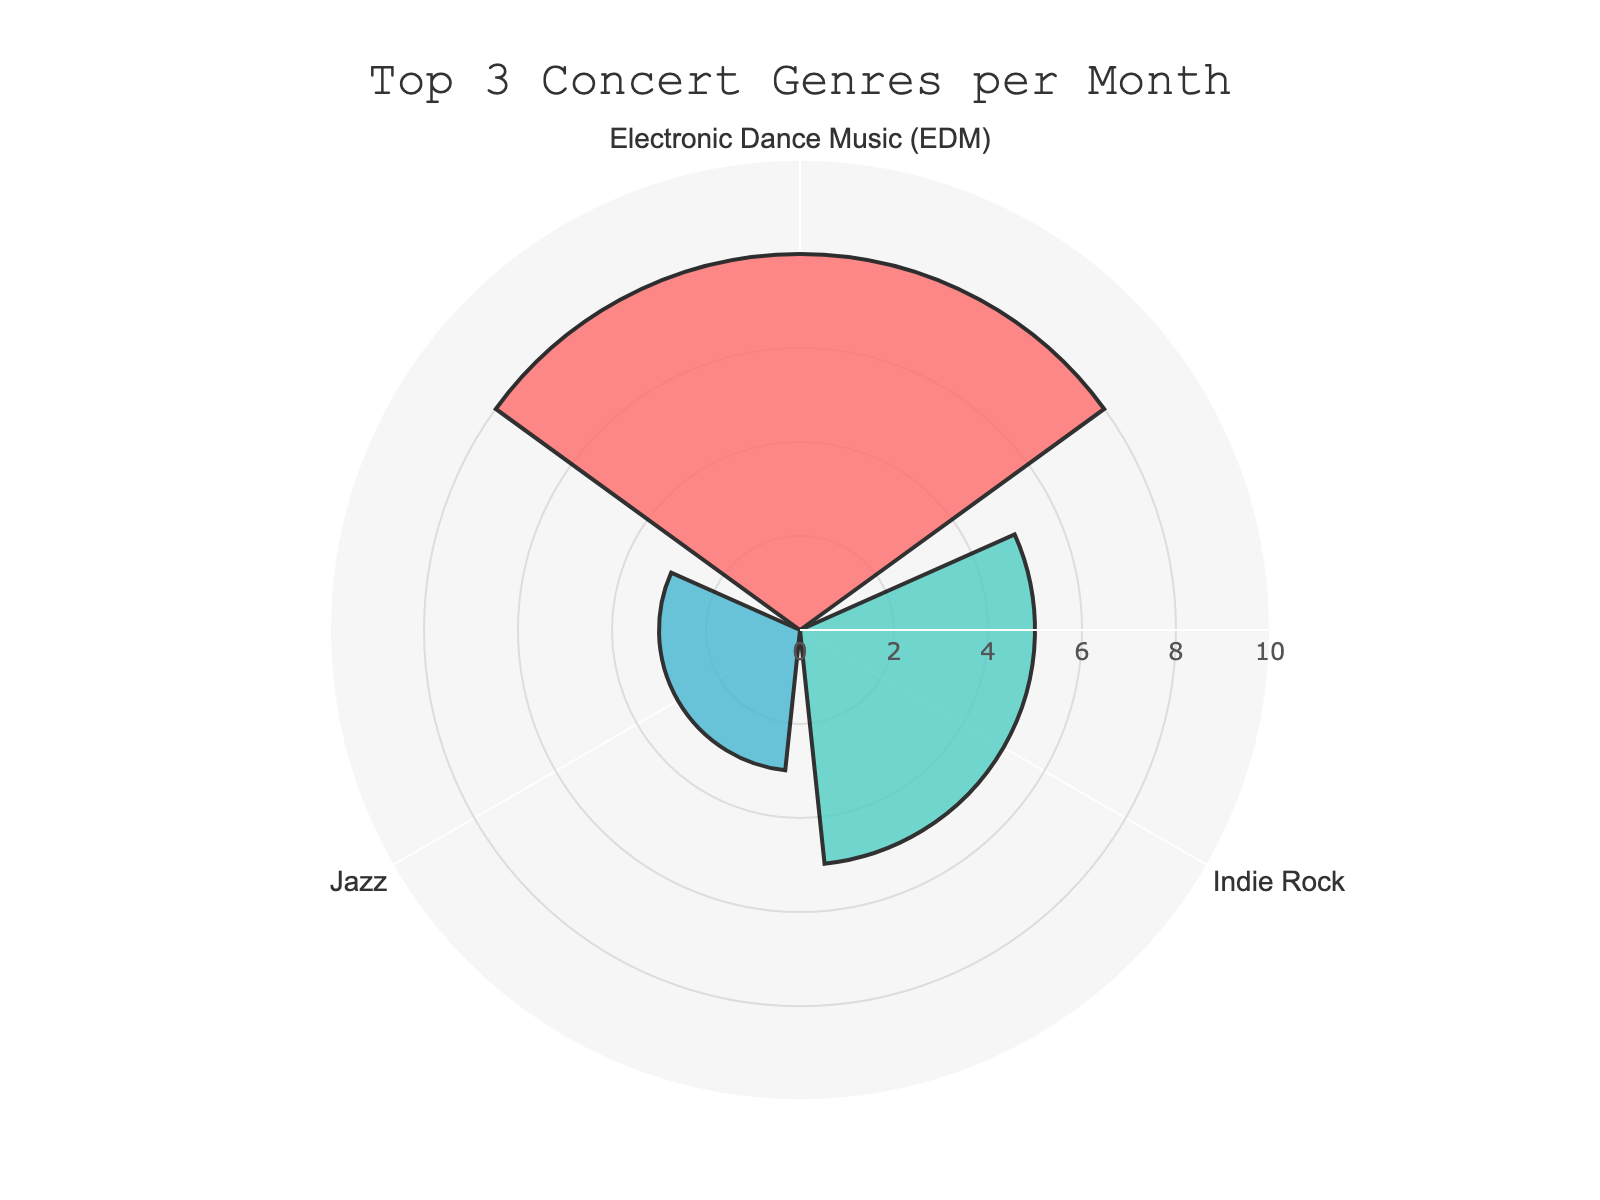What genres are included in the chart? The rose chart displays the concert attendance frequency for three music genres: Jazz, Electronic Dance Music (EDM), and Indie Rock. This is based on selecting the top 3 genres by concert attendance per month.
Answer: Jazz, Electronic Dance Music (EDM), and Indie Rock Which genre has the highest concert attendance per month? By observing the lengths of the bars in the rose chart, the genre with the longest bar corresponds to the highest concert attendance per month.
Answer: Electronic Dance Music (EDM) What colors represent each genre in the chart? The rose chart uses different colors to represent each genre: Jazz is marked in dark pinkish-red, Electronic Dance Music (EDM) in mint-green, and Indie Rock in blue.
Answer: Jazz: dark pinkish-red, Electronic Dance Music (EDM): mint-green, Indie Rock: blue What is the general trend in concert attendance per month among the top 3 genres? Analyzing the lengths of the bars, Electronic Dance Music (EDM) has the highest attendance, followed by Indie Rock, and Jazz has the lowest among the top three genres.
Answer: EDM > Indie Rock > Jazz How many more concerts per month does Electronic Dance Music (EDM) have compared to Jazz? By comparing the lengths of the bars, Electronic Dance Music (EDM) has 8 concerts per month and Jazz has 3. Subtracting these figures gives the difference.
Answer: 5 What is the average concert attendance per month for the top 3 genres? To find the average, sum the concert attendances for the top 3 genres (3 + 8 + 5) and divide by 3. The sum is 16, and dividing by 3 gives approximately 5.33.
Answer: 5.33 For which genre is concert attendance closest to 5 concerts per month? By looking at the rose chart, the bar representing 5 concerts per month corresponds to the Indie Rock genre.
Answer: Indie Rock Is Classical music included in the top 3 genres in terms of concert attendance? By referring to the title and the three bars shown in the chart, it is clear that Classical music, which has only 2 concerts per month, is not included in the top 3 genres.
Answer: No 